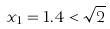<formula> <loc_0><loc_0><loc_500><loc_500>x _ { 1 } = 1 . 4 < \sqrt { 2 }</formula> 